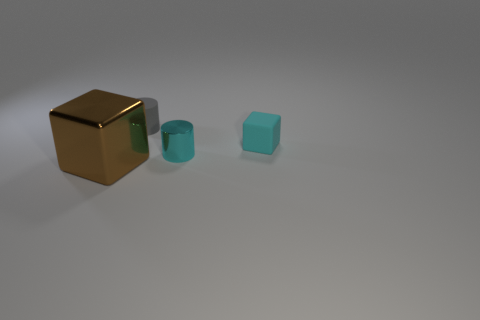Are there any other things that have the same size as the gray cylinder?
Your response must be concise. Yes. What is the color of the small thing that is the same material as the tiny gray cylinder?
Ensure brevity in your answer.  Cyan. What size is the thing that is both on the left side of the metal cylinder and in front of the tiny gray cylinder?
Your response must be concise. Large. Is the number of small metal cylinders that are behind the small rubber cylinder less than the number of tiny cylinders on the left side of the cyan shiny cylinder?
Your answer should be very brief. Yes. Do the thing that is in front of the small shiny cylinder and the cube on the right side of the gray matte thing have the same material?
Ensure brevity in your answer.  No. There is another tiny thing that is the same color as the tiny metal thing; what material is it?
Ensure brevity in your answer.  Rubber. What shape is the thing that is in front of the cyan matte cube and on the right side of the small gray rubber cylinder?
Make the answer very short. Cylinder. There is a cylinder that is in front of the matte thing right of the small gray matte object; what is its material?
Offer a very short reply. Metal. Is the number of large metallic objects greater than the number of tiny purple balls?
Your answer should be compact. Yes. Does the metal cylinder have the same color as the rubber block?
Your answer should be compact. Yes. 